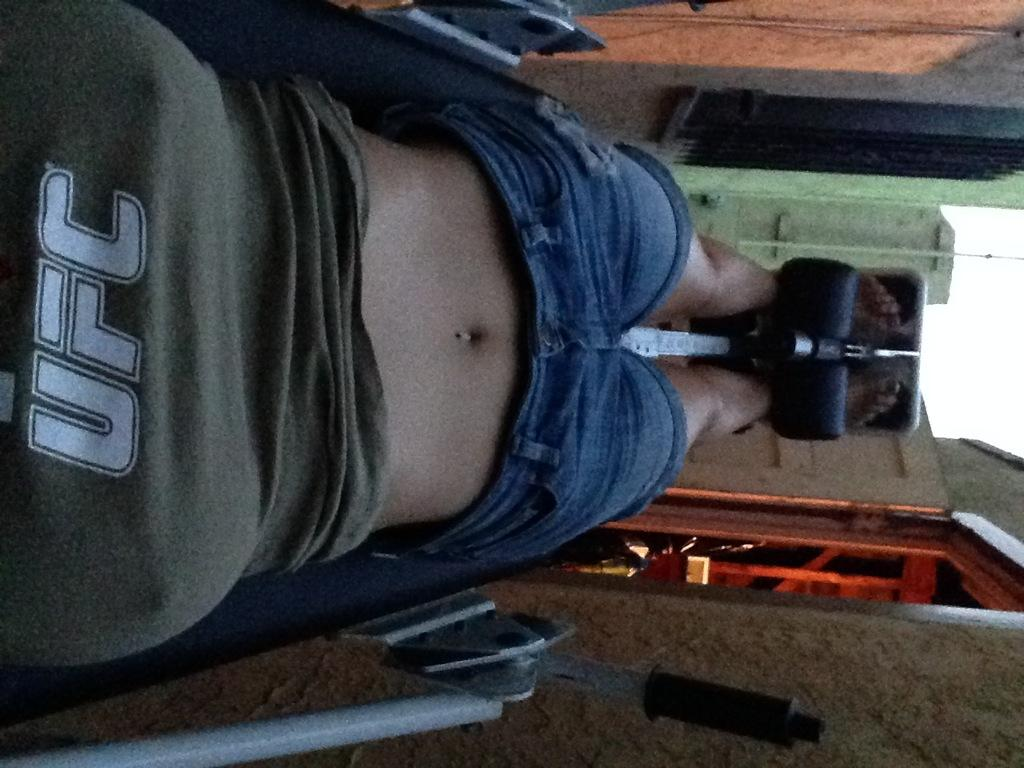Who is the main subject in the foreground of the image? There is a woman in the foreground of the image. What is the woman doing in the image? The woman is lying on gym equipment. What can be seen in the background of the image? There is a wall, an entrance or doorway, a door, and a pole or pillar associated with the building in the background of the image. What part of the natural environment is visible in the image? The sky is visible in the background of the image. How many hands does the woman have in the image? The number of hands the woman has cannot be determined from the image, as it only shows her lying on gym equipment. 